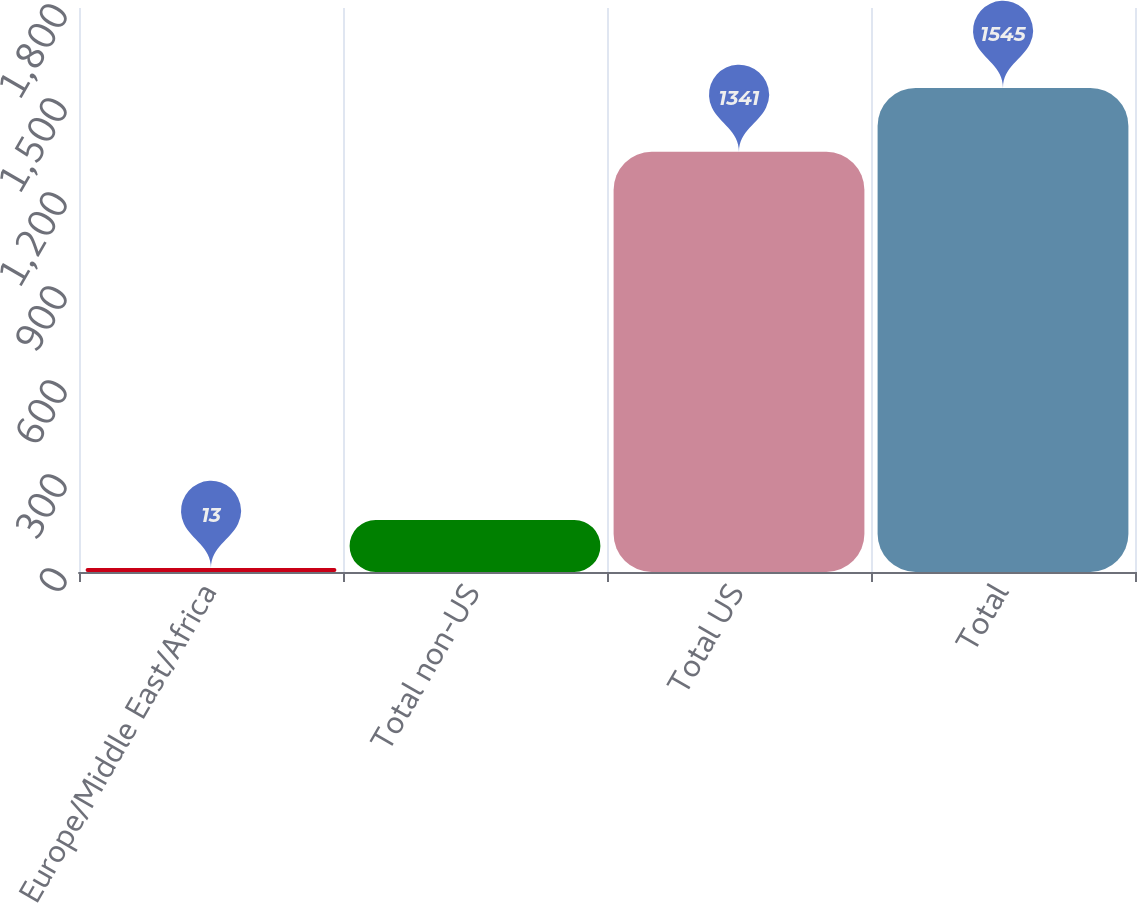<chart> <loc_0><loc_0><loc_500><loc_500><bar_chart><fcel>Europe/Middle East/Africa<fcel>Total non-US<fcel>Total US<fcel>Total<nl><fcel>13<fcel>166.2<fcel>1341<fcel>1545<nl></chart> 